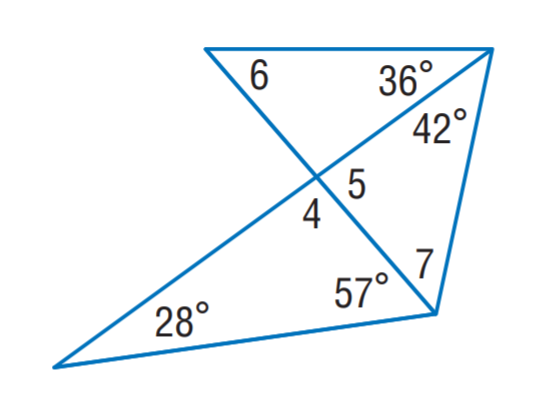Answer the mathemtical geometry problem and directly provide the correct option letter.
Question: Find m \angle 6.
Choices: A: 30 B: 49 C: 53 D: 85 B 